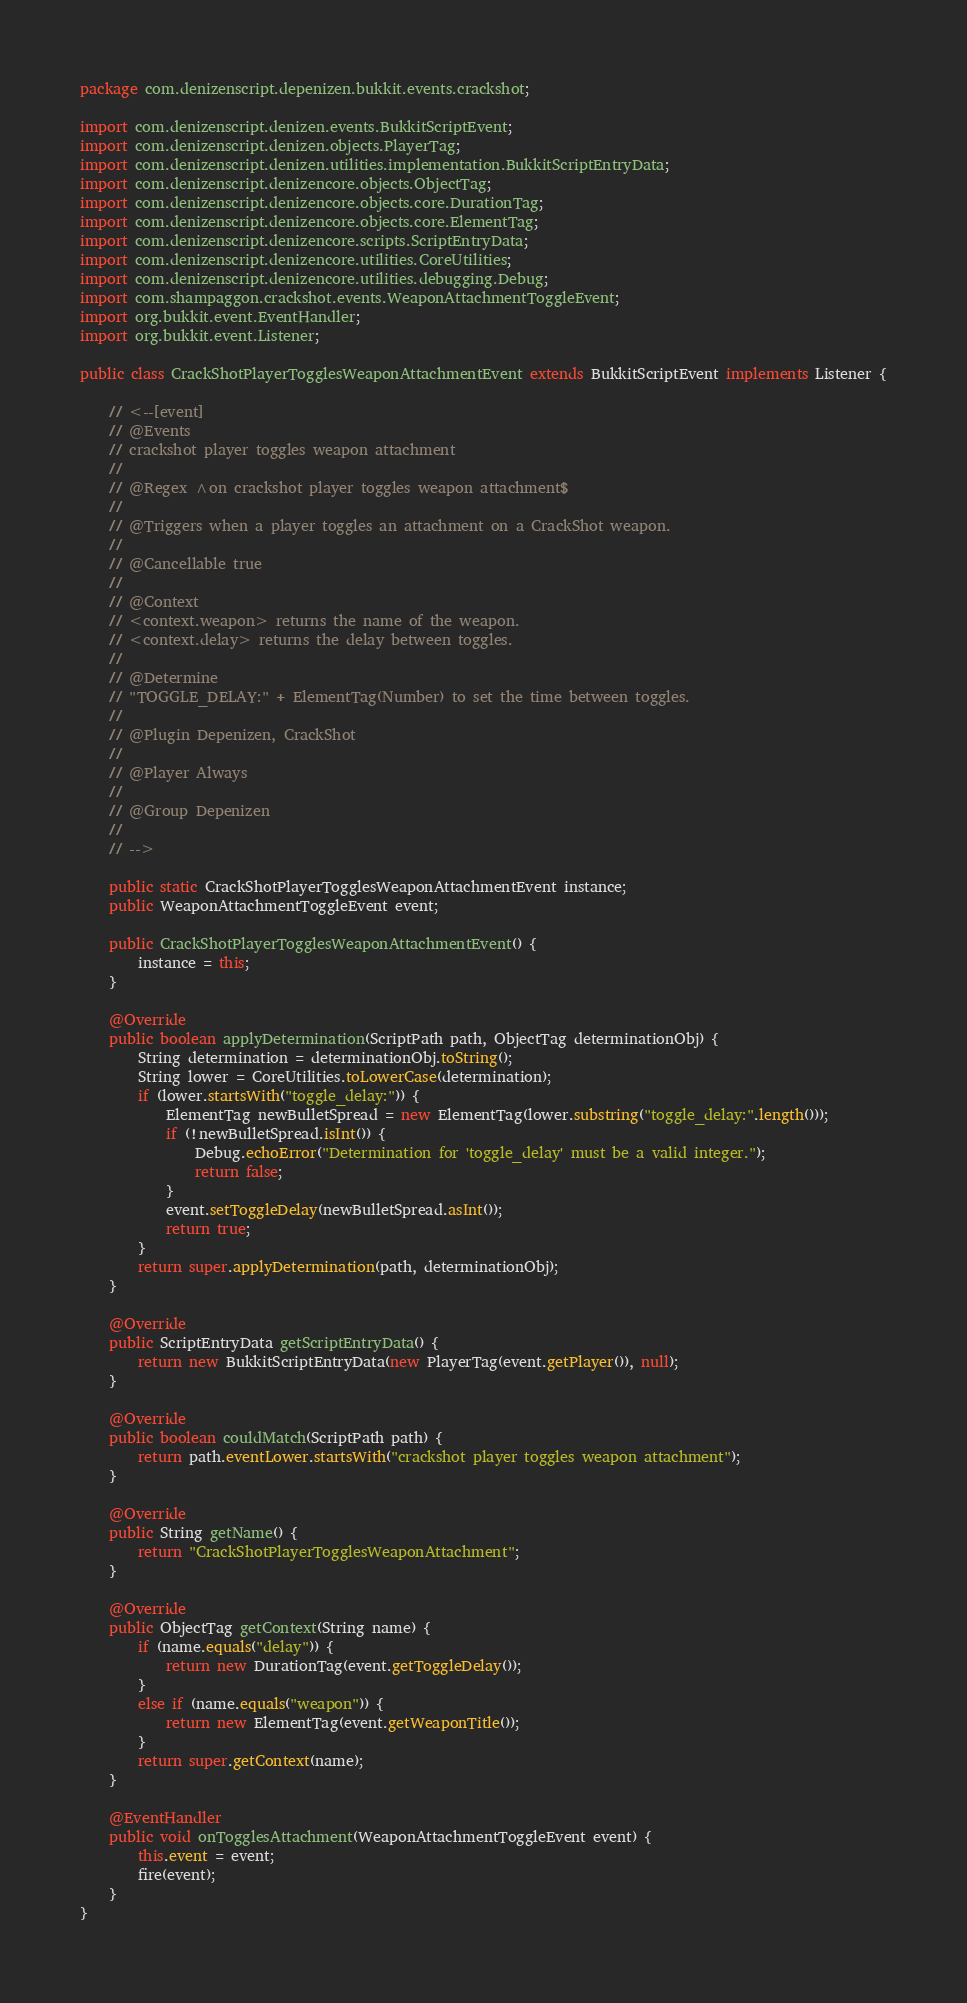<code> <loc_0><loc_0><loc_500><loc_500><_Java_>package com.denizenscript.depenizen.bukkit.events.crackshot;

import com.denizenscript.denizen.events.BukkitScriptEvent;
import com.denizenscript.denizen.objects.PlayerTag;
import com.denizenscript.denizen.utilities.implementation.BukkitScriptEntryData;
import com.denizenscript.denizencore.objects.ObjectTag;
import com.denizenscript.denizencore.objects.core.DurationTag;
import com.denizenscript.denizencore.objects.core.ElementTag;
import com.denizenscript.denizencore.scripts.ScriptEntryData;
import com.denizenscript.denizencore.utilities.CoreUtilities;
import com.denizenscript.denizencore.utilities.debugging.Debug;
import com.shampaggon.crackshot.events.WeaponAttachmentToggleEvent;
import org.bukkit.event.EventHandler;
import org.bukkit.event.Listener;

public class CrackShotPlayerTogglesWeaponAttachmentEvent extends BukkitScriptEvent implements Listener {

    // <--[event]
    // @Events
    // crackshot player toggles weapon attachment
    //
    // @Regex ^on crackshot player toggles weapon attachment$
    //
    // @Triggers when a player toggles an attachment on a CrackShot weapon.
    //
    // @Cancellable true
    //
    // @Context
    // <context.weapon> returns the name of the weapon.
    // <context.delay> returns the delay between toggles.
    //
    // @Determine
    // "TOGGLE_DELAY:" + ElementTag(Number) to set the time between toggles.
    //
    // @Plugin Depenizen, CrackShot
    //
    // @Player Always
    //
    // @Group Depenizen
    //
    // -->

    public static CrackShotPlayerTogglesWeaponAttachmentEvent instance;
    public WeaponAttachmentToggleEvent event;

    public CrackShotPlayerTogglesWeaponAttachmentEvent() {
        instance = this;
    }

    @Override
    public boolean applyDetermination(ScriptPath path, ObjectTag determinationObj) {
        String determination = determinationObj.toString();
        String lower = CoreUtilities.toLowerCase(determination);
        if (lower.startsWith("toggle_delay:")) {
            ElementTag newBulletSpread = new ElementTag(lower.substring("toggle_delay:".length()));
            if (!newBulletSpread.isInt()) {
                Debug.echoError("Determination for 'toggle_delay' must be a valid integer.");
                return false;
            }
            event.setToggleDelay(newBulletSpread.asInt());
            return true;
        }
        return super.applyDetermination(path, determinationObj);
    }

    @Override
    public ScriptEntryData getScriptEntryData() {
        return new BukkitScriptEntryData(new PlayerTag(event.getPlayer()), null);
    }

    @Override
    public boolean couldMatch(ScriptPath path) {
        return path.eventLower.startsWith("crackshot player toggles weapon attachment");
    }

    @Override
    public String getName() {
        return "CrackShotPlayerTogglesWeaponAttachment";
    }

    @Override
    public ObjectTag getContext(String name) {
        if (name.equals("delay")) {
            return new DurationTag(event.getToggleDelay());
        }
        else if (name.equals("weapon")) {
            return new ElementTag(event.getWeaponTitle());
        }
        return super.getContext(name);
    }

    @EventHandler
    public void onTogglesAttachment(WeaponAttachmentToggleEvent event) {
        this.event = event;
        fire(event);
    }
}
</code> 